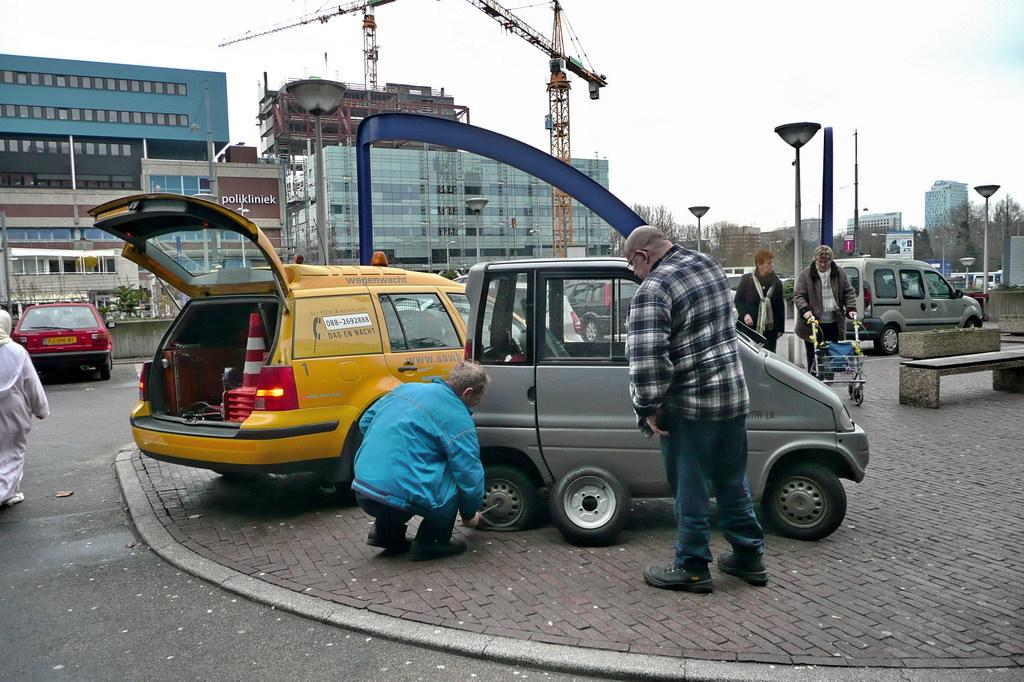<image>
Write a terse but informative summary of the picture. Two men are trying to change a car tire and the repair vehicle next to it says wegenwacht. 